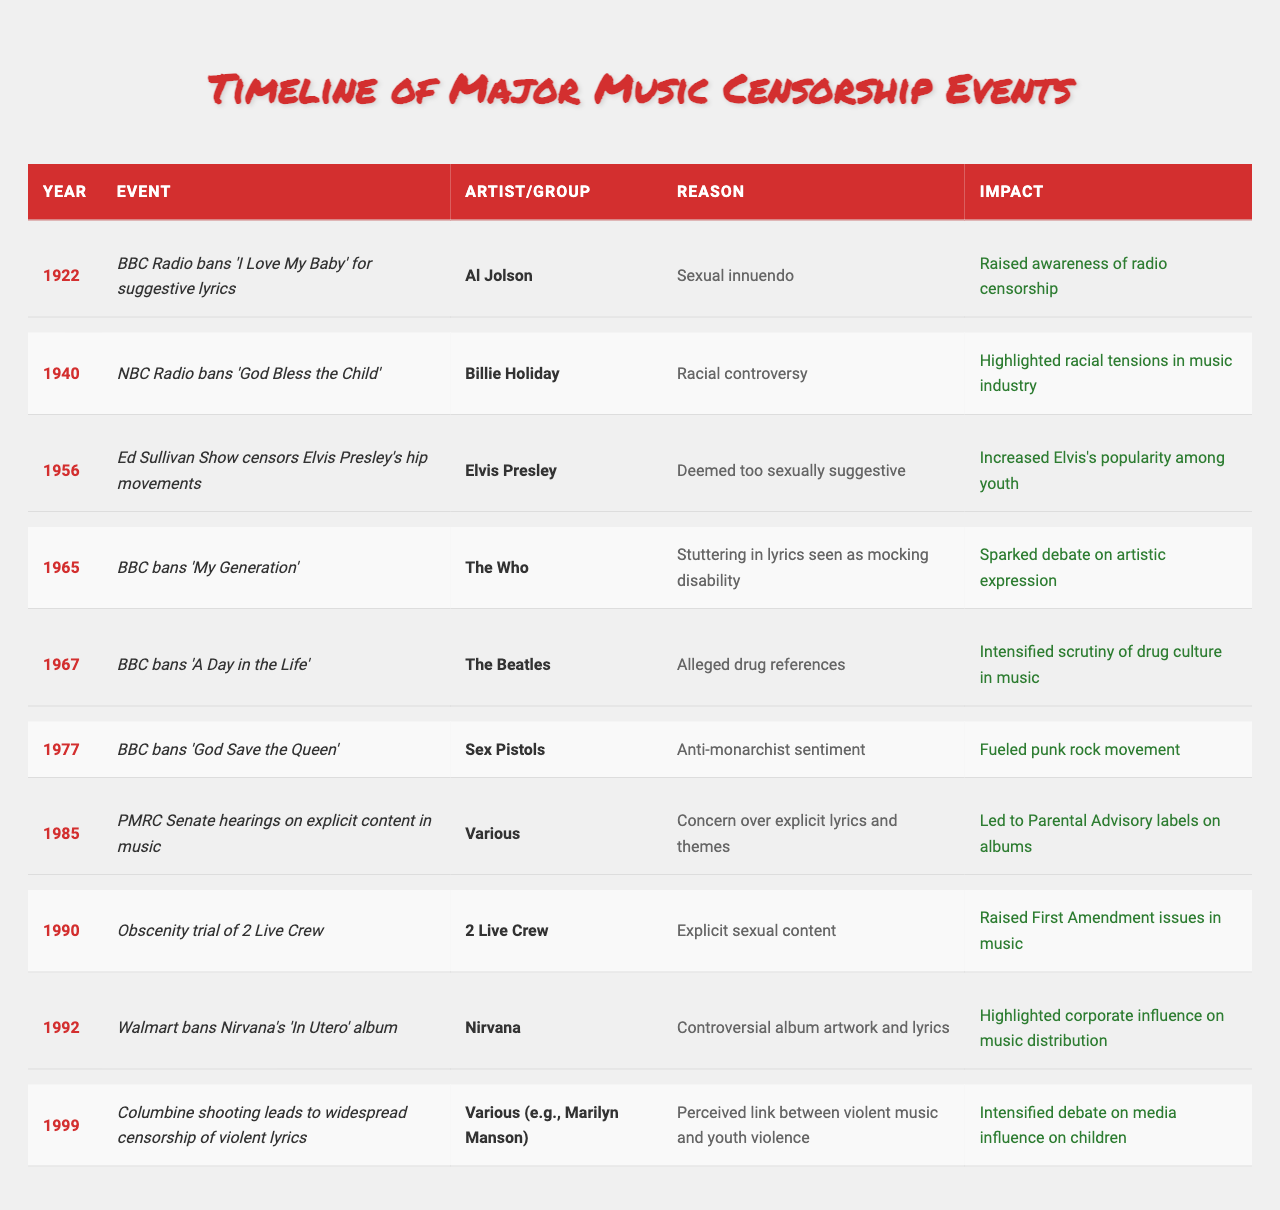What year did the BBC first ban a song for suggestive lyrics? The table shows that the BBC Radio banned "I Love My Baby" by Al Jolson in 1922 due to suggestive lyrics.
Answer: 1922 Which artist’s hip movements were censored on the Ed Sullivan Show? The table indicates that Elvis Presley’s hip movements were censored on the Ed Sullivan Show in 1956.
Answer: Elvis Presley What was the impact of the 1985 PMRC Senate hearings? According to the table, the hearings led to Parental Advisory labels on albums, indicating a significant result from the hearings.
Answer: Led to Parental Advisory labels How many events listed in the table involved the BBC as the censor? By counting the entries in the table, there are four events in which the BBC banned songs from 1922, 1965, 1967, and 1977.
Answer: Four Was the censorship of "God Bless the Child" in 1940 related to racial issues? The table states that this song was banned due to racial controversy, confirming that the censorship was indeed related to racial issues.
Answer: Yes What was the common reason for censorship in both 1990 and 1999 events? The table shows that the reasons for the events in 1990 (2 Live Crew's obscenity trial) and 1999 (Columbine shooting's impact on violent lyrics) both relate to concerns over explicit or violent content affecting youth.
Answer: Explicit or violent content Compare the impacts of the bans from 1965 and 1977. What was the main difference? The impact of the 1965 ban of "My Generation" sparked debate on artistic expression, while the 1977 ban of "God Save the Queen" fueled the punk rock movement. This indicates a shift from artistic expression debates to a cultural movement.
Answer: Different cultural impacts (debate vs. movement) What artist was involved in the event that raised First Amendment issues in music? The event associated with First Amendment issues in music involved 2 Live Crew, as indicated in the table for the year 1990.
Answer: 2 Live Crew How did the 1992 ban of Nirvana's album reflect corporate influence? The table notes that Walmart banned Nirvana's "In Utero" due to controversial artwork and lyrics, highlighting the corporate influence on music distribution.
Answer: Corporate influence on distribution What trend can be observed about the reasons for censorship from the 1920s through the 1990s? Analyzing the reasons listed in the table, there is a progression from sexual innuendo in the 1920s, to racial controversy in the 1940s, sexual suggestiveness in the 1950s, to explicit lyrics and violent content by the 1990s, showing a widening scope of censorship.
Answer: Widening scope from sexual to violent content 